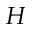<formula> <loc_0><loc_0><loc_500><loc_500>H</formula> 